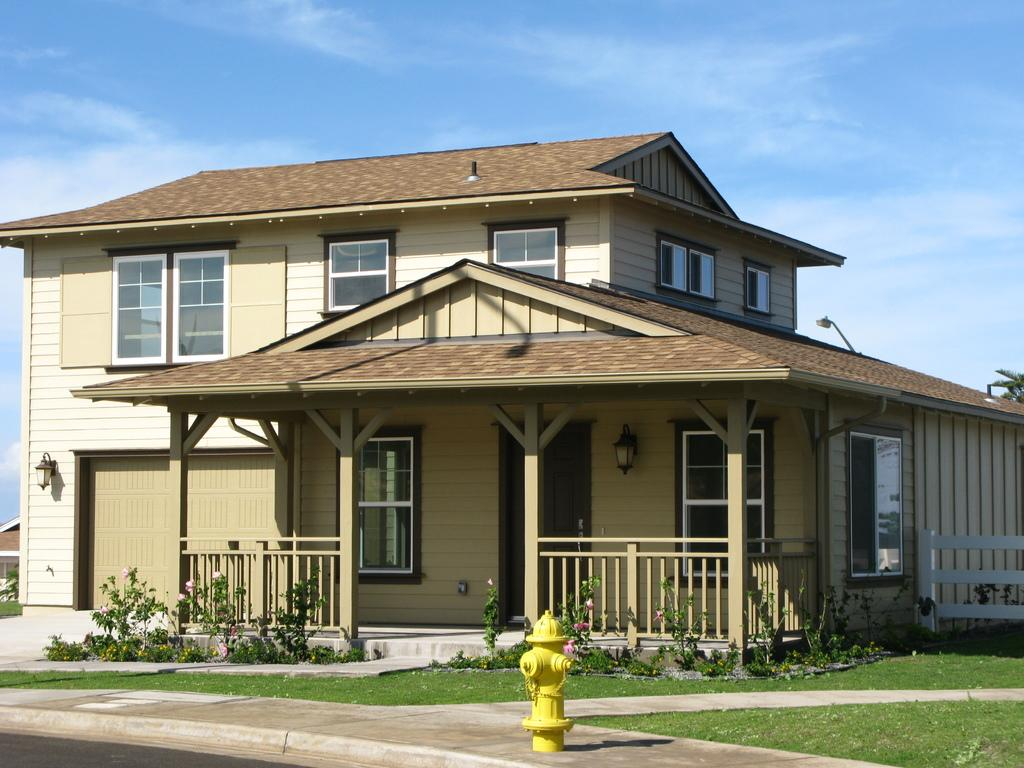What is the main structure in the center of the image? There is a building in the center of the image. What object can be found at the bottom of the image? There is a hydrant at the bottom of the image. What type of vegetation is visible in the image? Shrubs are visible in the image. What part of the natural environment is visible in the image? The sky is visible in the background of the image. What type of eggnog is being served in the image? There is no eggnog present in the image. What type of car is parked near the hydrant in the image? There is no car present in the image. 